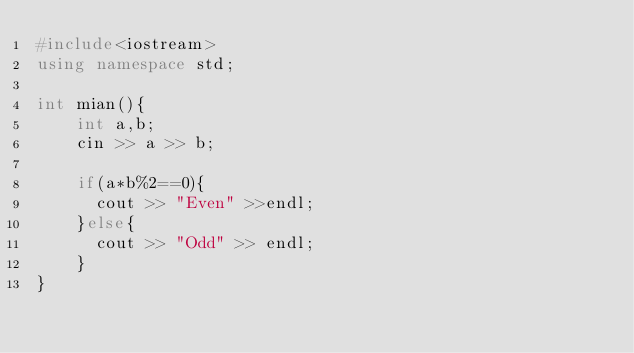<code> <loc_0><loc_0><loc_500><loc_500><_C++_>#include<iostream>
using namespace std;

int mian(){
	int a,b;
  	cin >> a >> b;
  
  	if(a*b%2==0){
      cout >> "Even" >>endl;
    }else{
      cout >> "Odd" >> endl;
    }
}</code> 